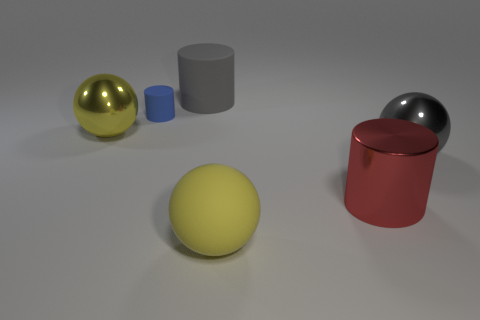Subtract all big yellow matte balls. How many balls are left? 2 Add 4 large brown cylinders. How many objects exist? 10 Subtract all red blocks. How many yellow balls are left? 2 Subtract 3 balls. How many balls are left? 0 Subtract all blue cylinders. How many cylinders are left? 2 Add 1 yellow matte objects. How many yellow matte objects exist? 2 Subtract 1 blue cylinders. How many objects are left? 5 Subtract all green cylinders. Subtract all gray balls. How many cylinders are left? 3 Subtract all shiny balls. Subtract all matte cylinders. How many objects are left? 2 Add 1 rubber balls. How many rubber balls are left? 2 